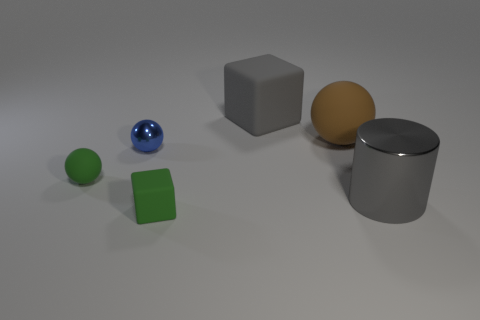What material is the large object that is the same color as the metal cylinder?
Your answer should be very brief. Rubber. The metal cylinder has what color?
Provide a short and direct response. Gray. There is a rubber object to the left of the small green block; is there a big brown ball that is to the left of it?
Keep it short and to the point. No. What is the large cylinder made of?
Your answer should be very brief. Metal. Is the block in front of the blue metallic object made of the same material as the big gray object that is to the right of the gray matte thing?
Give a very brief answer. No. Is there anything else that has the same color as the small metal sphere?
Your answer should be compact. No. There is another thing that is the same shape as the gray rubber thing; what color is it?
Your response must be concise. Green. There is a matte thing that is both to the right of the blue metal thing and on the left side of the gray cube; how big is it?
Your answer should be compact. Small. Is the shape of the big rubber object to the left of the brown ball the same as the large thing on the right side of the brown thing?
Ensure brevity in your answer.  No. There is a large object that is the same color as the cylinder; what is its shape?
Your answer should be very brief. Cube. 